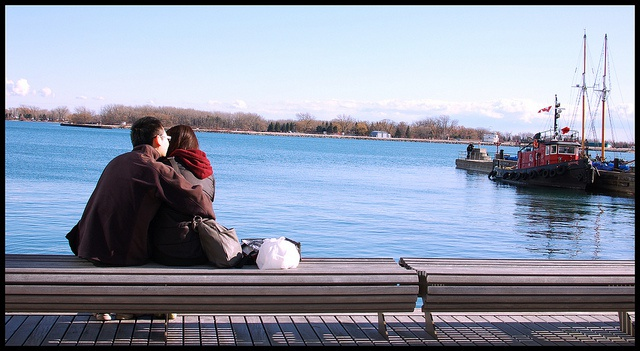Describe the objects in this image and their specific colors. I can see bench in black, gray, and darkgray tones, bench in black, gray, darkgray, and lavender tones, boat in black, lavender, gray, and maroon tones, people in black, brown, and maroon tones, and people in black, maroon, darkgray, and gray tones in this image. 